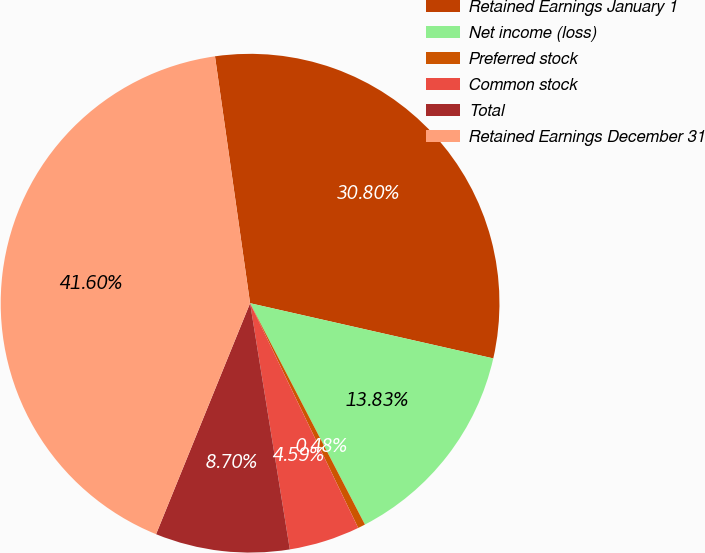<chart> <loc_0><loc_0><loc_500><loc_500><pie_chart><fcel>Retained Earnings January 1<fcel>Net income (loss)<fcel>Preferred stock<fcel>Common stock<fcel>Total<fcel>Retained Earnings December 31<nl><fcel>30.8%<fcel>13.83%<fcel>0.48%<fcel>4.59%<fcel>8.7%<fcel>41.6%<nl></chart> 